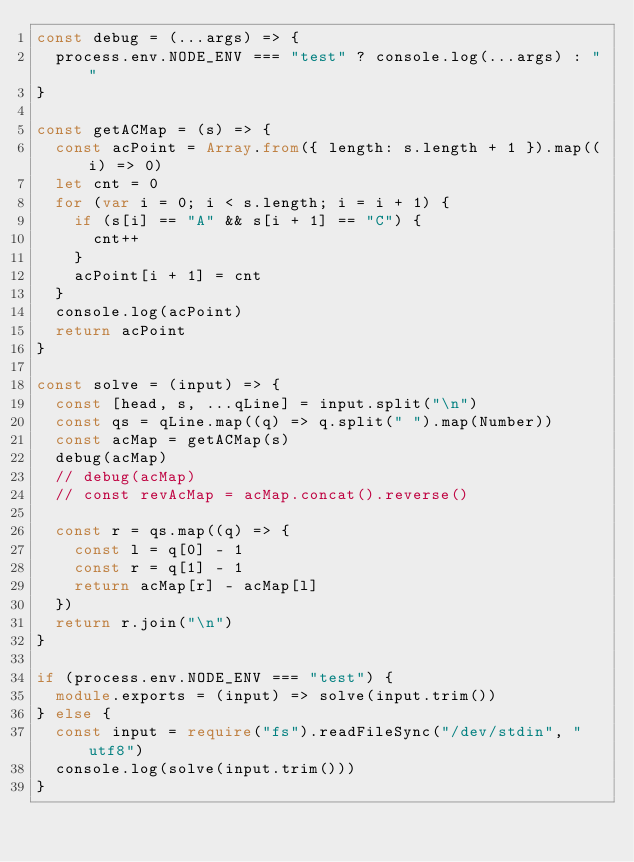<code> <loc_0><loc_0><loc_500><loc_500><_TypeScript_>const debug = (...args) => {
  process.env.NODE_ENV === "test" ? console.log(...args) : ""
}

const getACMap = (s) => {
  const acPoint = Array.from({ length: s.length + 1 }).map((i) => 0)
  let cnt = 0
  for (var i = 0; i < s.length; i = i + 1) {
    if (s[i] == "A" && s[i + 1] == "C") {
      cnt++
    }
    acPoint[i + 1] = cnt
  }
  console.log(acPoint)
  return acPoint
}

const solve = (input) => {
  const [head, s, ...qLine] = input.split("\n")
  const qs = qLine.map((q) => q.split(" ").map(Number))
  const acMap = getACMap(s)
  debug(acMap)
  // debug(acMap)
  // const revAcMap = acMap.concat().reverse()

  const r = qs.map((q) => {
    const l = q[0] - 1
    const r = q[1] - 1
    return acMap[r] - acMap[l]
  })
  return r.join("\n")
}

if (process.env.NODE_ENV === "test") {
  module.exports = (input) => solve(input.trim())
} else {
  const input = require("fs").readFileSync("/dev/stdin", "utf8")
  console.log(solve(input.trim()))
}
</code> 